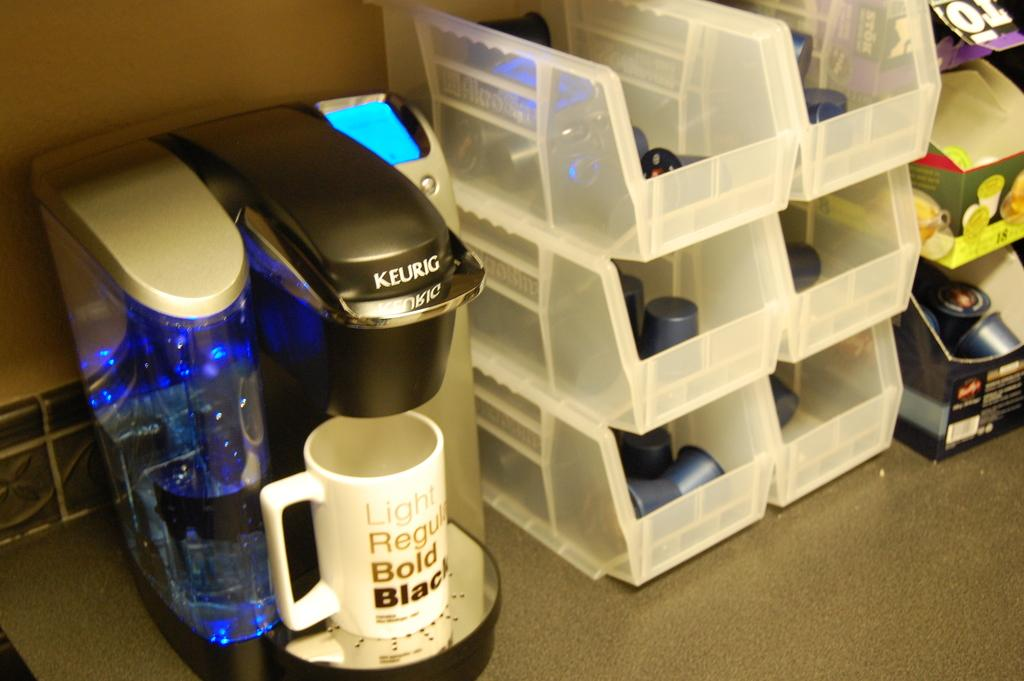Provide a one-sentence caption for the provided image. A Keurig with a coffee cup that says Light, Regular, Bold, Black is shown on a counter next to containers of creamer. 